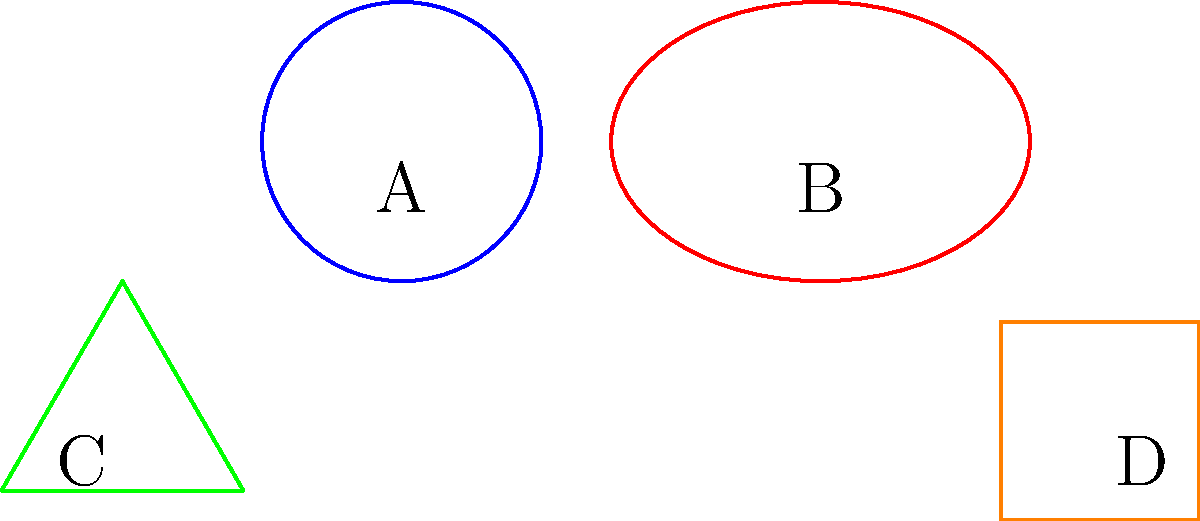In a digital art installation, four geometric shapes are used as interactive elements. These shapes, labeled A, B, C, and D, need to be classified based on their topological properties. Which of these shapes are homeomorphic to each other? To determine which shapes are homeomorphic, we need to consider their topological properties:

1. Shape A is a circle.
2. Shape B is an ellipse.
3. Shape C is a triangle.
4. Shape D is a square.

Step 1: Recall that homeomorphic shapes can be continuously deformed into each other without cutting or gluing.

Step 2: Analyze each shape:
- A circle (A) and an ellipse (B) are homeomorphic because an ellipse can be continuously deformed into a circle and vice versa.
- A triangle (C) and a square (D) are homeomorphic because they are both simple closed polygons that can be continuously deformed into each other.

Step 3: Compare the two groups:
- The circle/ellipse group (A and B) has no corners and a single continuous curve.
- The triangle/square group (C and D) has corners and straight edges.

Step 4: Conclude that A and B form one homeomorphic group, while C and D form another homeomorphic group. These two groups are not homeomorphic to each other due to their fundamentally different structures (presence or absence of corners).
Answer: A and B; C and D 